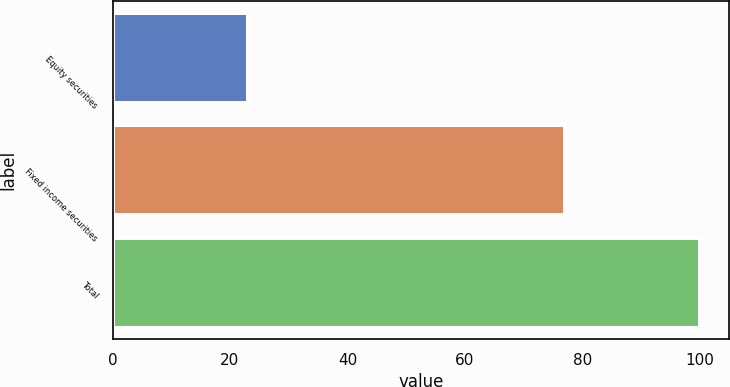Convert chart. <chart><loc_0><loc_0><loc_500><loc_500><bar_chart><fcel>Equity securities<fcel>Fixed income securities<fcel>Total<nl><fcel>23<fcel>77<fcel>100<nl></chart> 